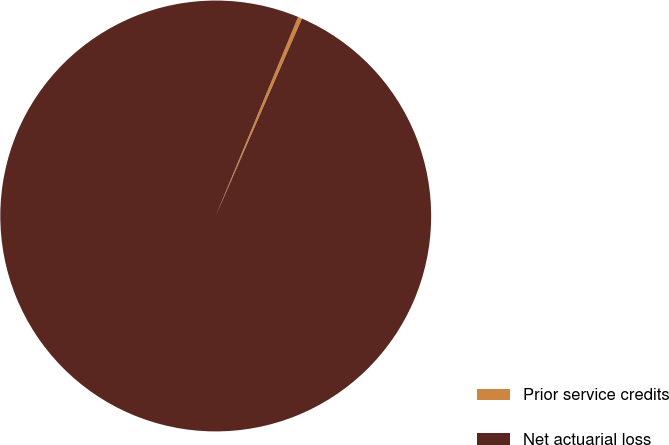Convert chart to OTSL. <chart><loc_0><loc_0><loc_500><loc_500><pie_chart><fcel>Prior service credits<fcel>Net actuarial loss<nl><fcel>0.31%<fcel>99.69%<nl></chart> 